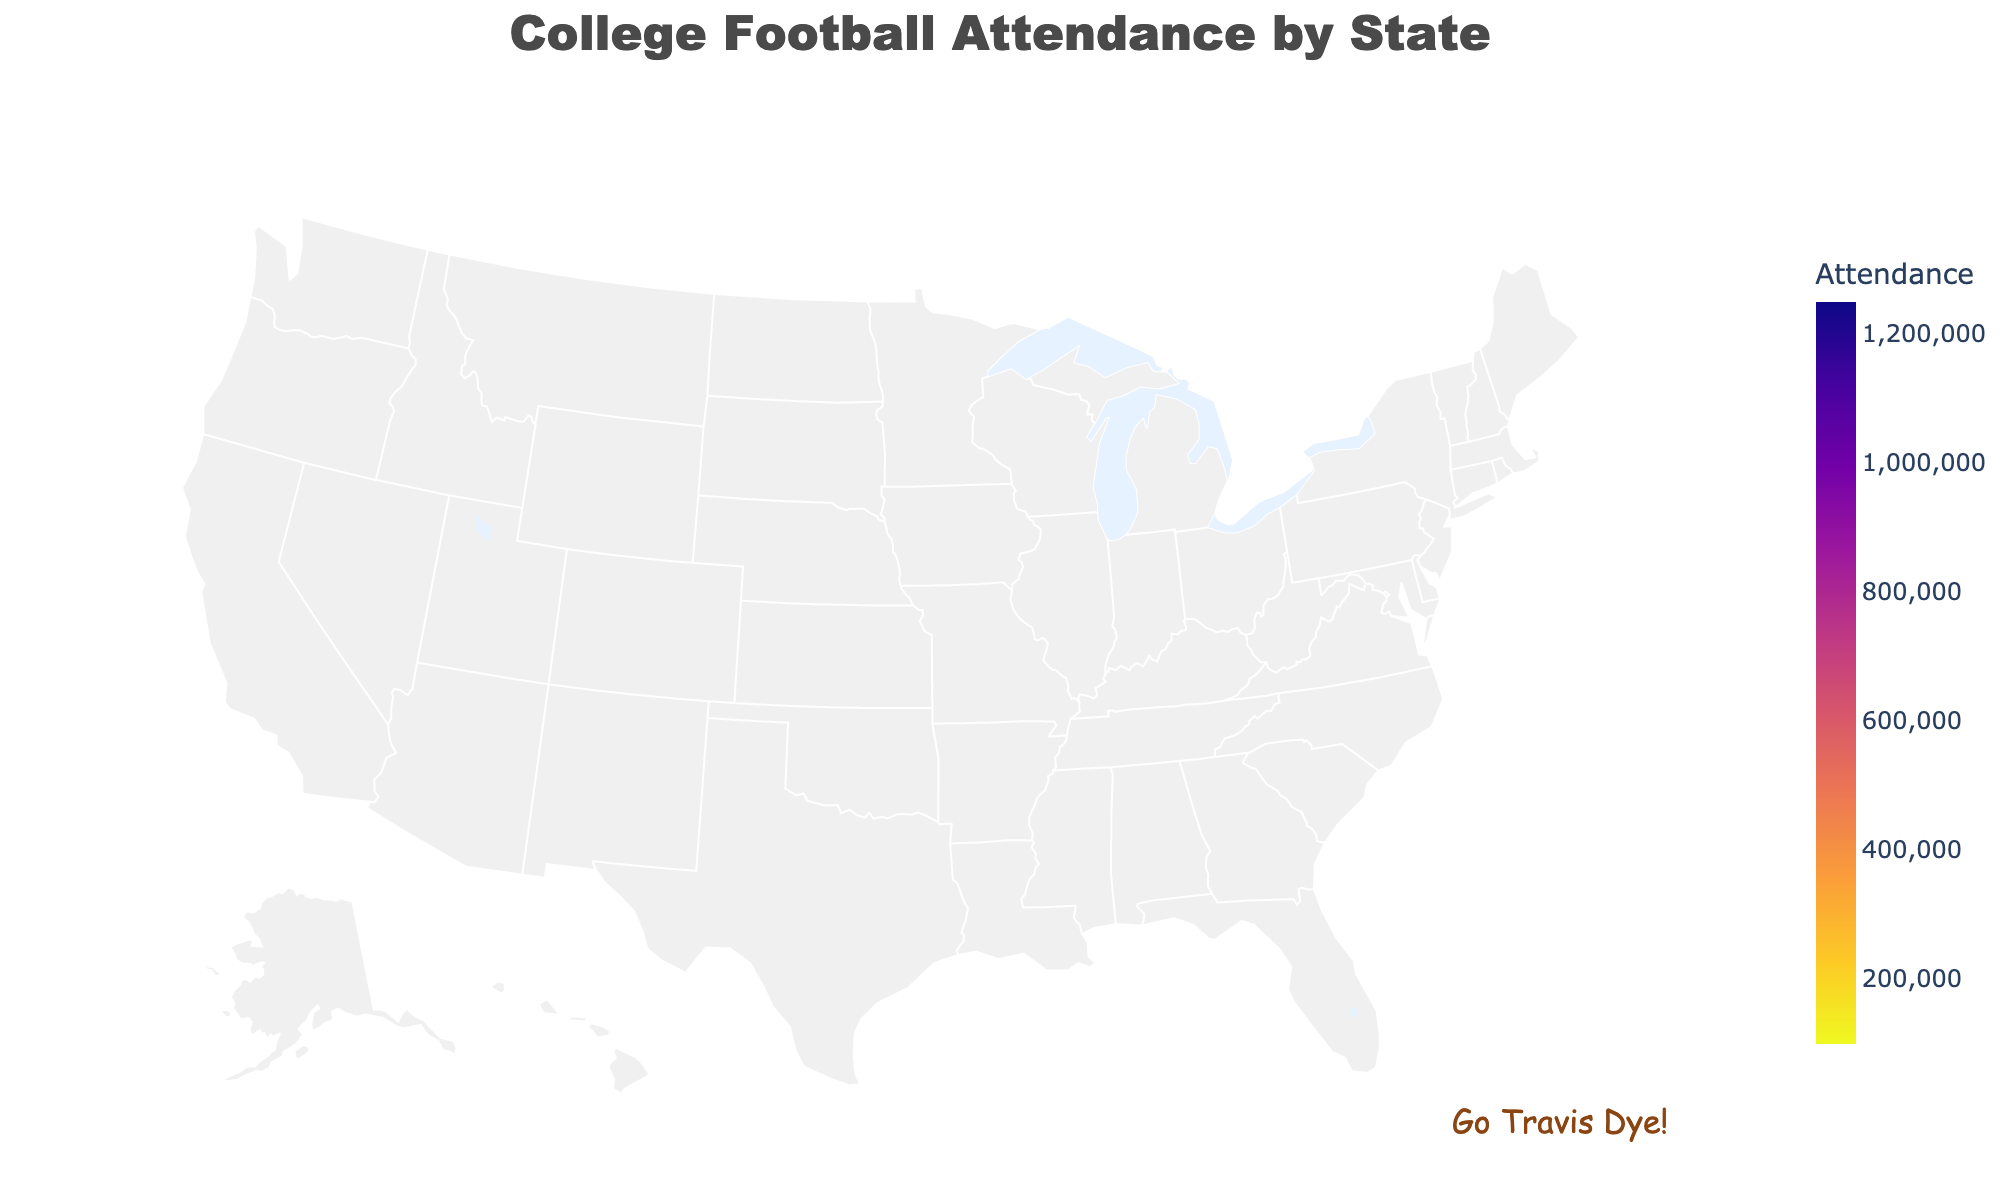What's the title of the figure? The title is displayed prominently at the top of the figure, usually in a larger font size. It gives an overview of the content.
Answer: College Football Attendance by State Which state has the highest attendance? By observing the color scale and hovering over or checking the labeled attendance values, we can determine the state with the highest figure.
Answer: Alabama Which state has the lowest attendance? By finding the state with the lowest value in the attendance scale and confirming it matches the figure shown, we can identify the least attended state.
Answer: Colorado How many states have attendance figures above 1,000,000? By checking the attendance values, count the number of states where the value exceeds 1,000,000.
Answer: 2 How does Florida's attendance compare to Georgia's? Compare the attendance values for Florida and Georgia as provided in the data or the figure.
Answer: Florida has a higher attendance than Georgia What's the average attendance for the states listed? Sum all attendance figures and divide by the number of states (20 states in total). The sum is (1250000 + 1150000 + 950000 + 900000 + 850000 + 800000 + 750000 + 700000 + 650000 + 600000 + 550000 + 500000 + 450000 + 400000 + 350000 + 300000 + 250000 + 200000 + 150000 + 100000) = 11,650,000. Dividing by 20 gives 582,500.
Answer: 582,500 Which state has a lower attendance: Texas or Ohio? Compare the attendance figures for Texas and Ohio listed in the data or visualized in the figure.
Answer: Ohio Which states have attendance figures between 500,000 and 800,000? Identify and list states with attendance figures within the given range.
Answer: South Carolina, Nebraska, Oregon, Wisconsin Are there more states with attendance figures below or above 500,000? Count the number of states with attendance below and above 500,000. Below: Colorado, Arizona, Washington, Kentucky, Arkansas, Mississippi, Iowa (7 states). Above: Alabama, Texas, Ohio, Michigan, Florida, Georgia, Oklahoma, Louisiana, Tennessee, South Carolina, Nebraska, Oregon, Wisconsin (13 states).
Answer: More above What does the annotation on the plot say? The annotation is added to provide additional information or context relevant to the data, usually in a distinct font or style.
Answer: Go Travis Dye! 